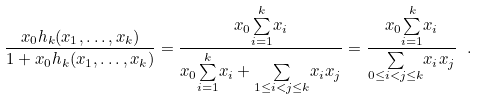<formula> <loc_0><loc_0><loc_500><loc_500>\frac { x _ { 0 } h _ { k } ( x _ { 1 } , \dots , x _ { k } ) } { 1 + x _ { 0 } h _ { k } ( x _ { 1 } , \dots , x _ { k } ) } = \frac { x _ { 0 } \overset { k } { \underset { i = 1 } { \sum } } x _ { i } } { x _ { 0 } \overset { k } { \underset { i = 1 } { \sum } } x _ { i } + \underset { 1 \leq i < j \leq k } { \sum } x _ { i } x _ { j } } = \frac { x _ { 0 } \overset { k } { \underset { i = 1 } { \sum } } x _ { i } } { \underset { 0 \leq i < j \leq k } { \sum } x _ { i } x _ { j } } \ .</formula> 